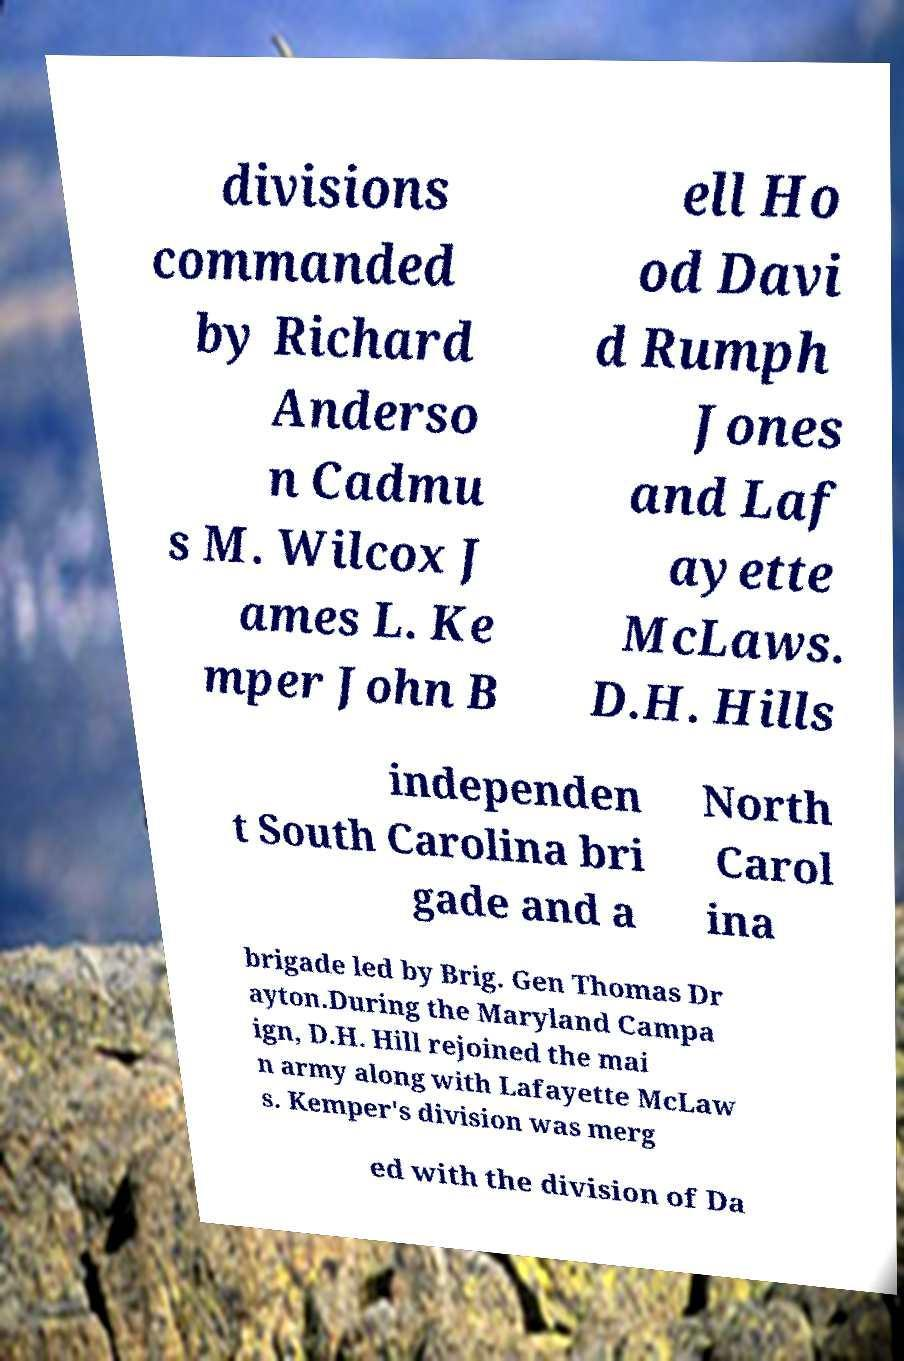There's text embedded in this image that I need extracted. Can you transcribe it verbatim? divisions commanded by Richard Anderso n Cadmu s M. Wilcox J ames L. Ke mper John B ell Ho od Davi d Rumph Jones and Laf ayette McLaws. D.H. Hills independen t South Carolina bri gade and a North Carol ina brigade led by Brig. Gen Thomas Dr ayton.During the Maryland Campa ign, D.H. Hill rejoined the mai n army along with Lafayette McLaw s. Kemper's division was merg ed with the division of Da 